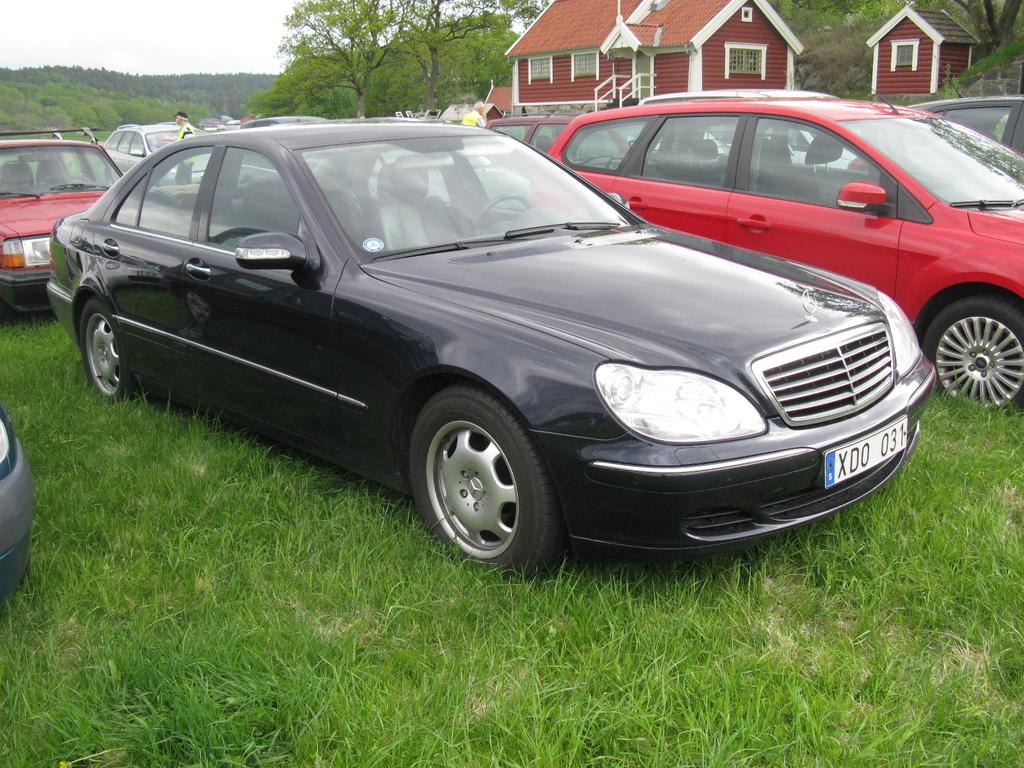What is located on the grass in the image? There are vehicles on the grass in the image. Who or what can be seen in the image besides the vehicles? There are people visible in the image. What can be seen in the distance in the image? There is a house and trees in the background of the image. What type of sticks are being used to pull the carriage in the image? There is no carriage present in the image, so there are no sticks being used to pull it. 